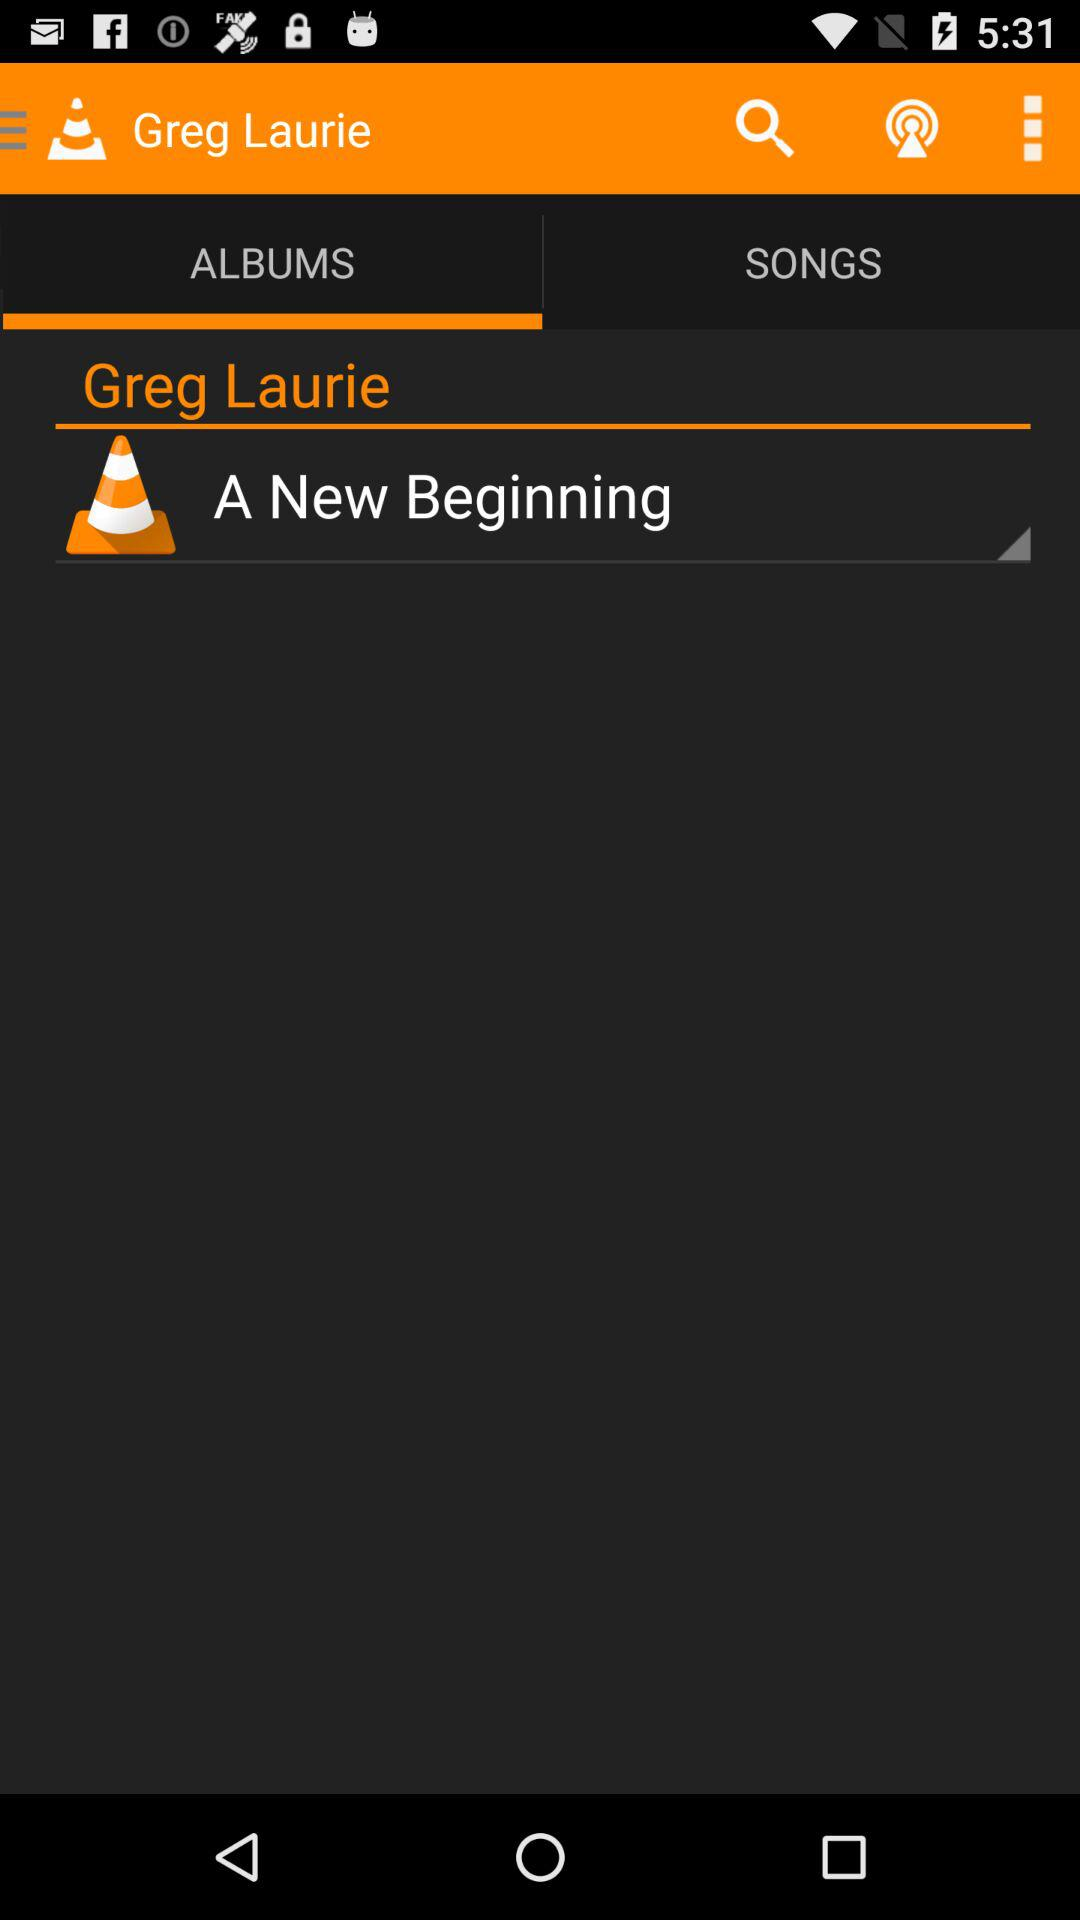What is the name of the artist? The name of the artist is "Greg Laurie". 